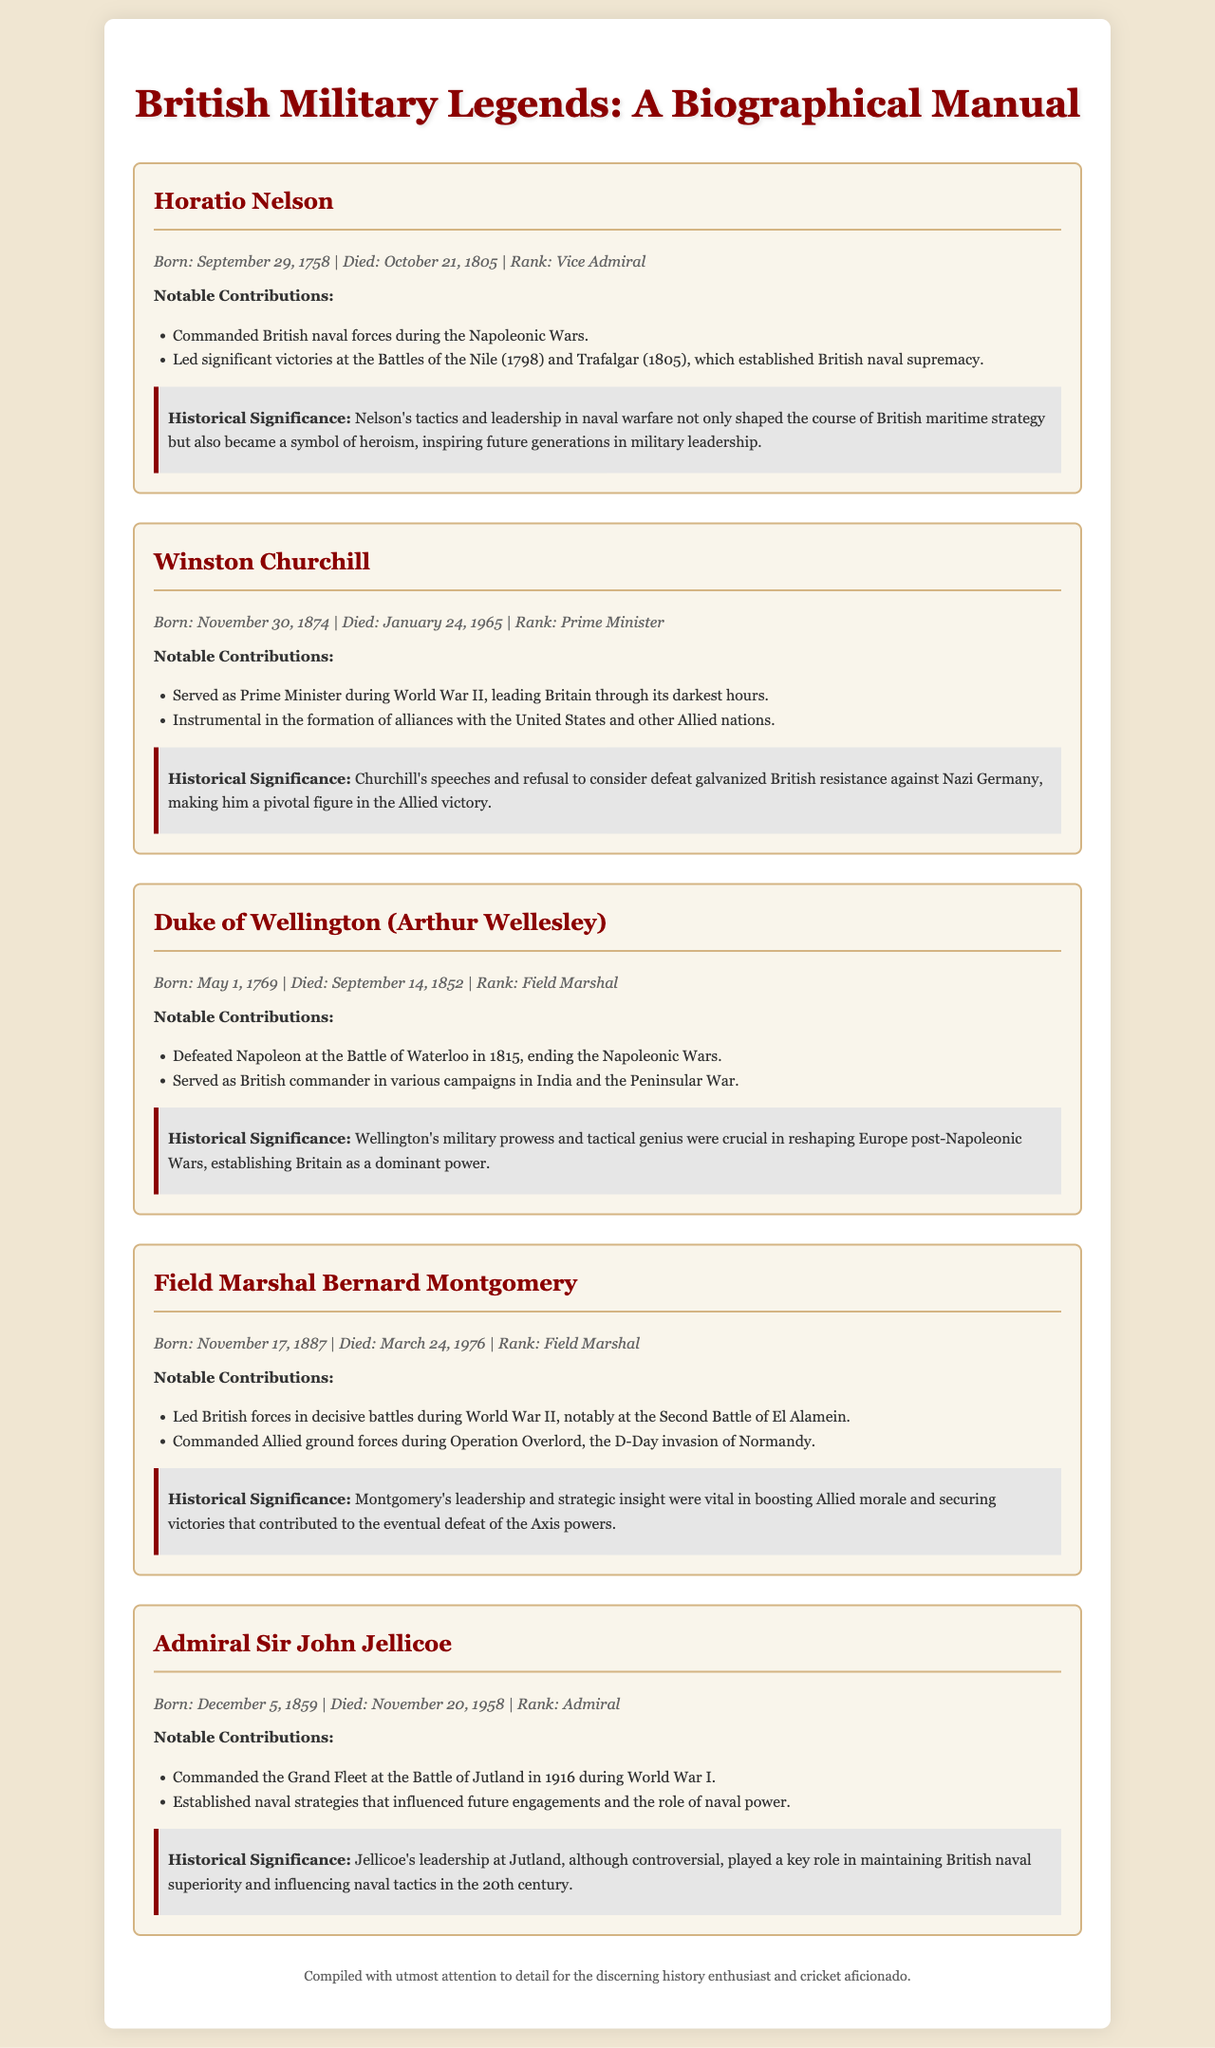What rank did Horatio Nelson hold? Horatio Nelson is identified as a Vice Admiral in the document.
Answer: Vice Admiral When was Winston Churchill born? The document states Winston Churchill was born on November 30, 1874.
Answer: November 30, 1874 What battle is associated with the Duke of Wellington? The document mentions the Battle of Waterloo as a significant event in the Duke of Wellington's military career.
Answer: Battle of Waterloo Who led British forces at the Second Battle of El Alamein? The document indicates that Field Marshal Bernard Montgomery led British forces at the Second Battle of El Alamein.
Answer: Field Marshal Bernard Montgomery What historical significance is attributed to Admiral Sir John Jellicoe's leadership? The document highlights that Jellicoe’s leadership was key in maintaining British naval superiority and influencing naval tactics.
Answer: Maintaining British naval superiority How did Churchill's speeches impact Britain during WWII? The document states that Churchill's speeches galvanized British resistance against Nazi Germany.
Answer: Galvanized British resistance What is a notable contribution of the Duke of Wellington besides the Battle of Waterloo? The document mentions that he served as British commander in various campaigns in India and the Peninsular War.
Answer: Various campaigns in India What is the overall theme of the document? The document is a biographical manual focused on notable figures in British military history.
Answer: British military history In what year did Admiral Sir John Jellicoe die? The document specifies that Admiral Sir John Jellicoe died on November 20, 1958.
Answer: November 20, 1958 